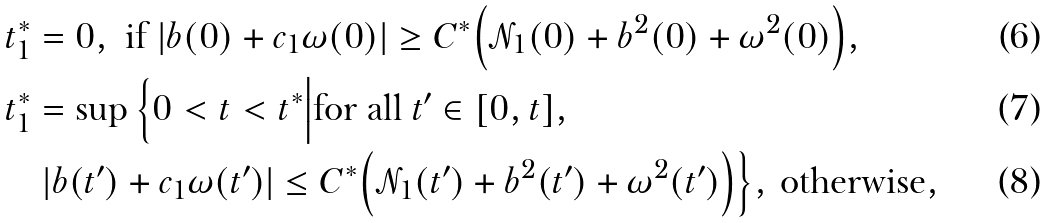<formula> <loc_0><loc_0><loc_500><loc_500>& t _ { 1 } ^ { * } = 0 , \text { if } | b ( 0 ) + c _ { 1 } \omega ( 0 ) | \geq C ^ { * } \Big ( \mathcal { N } _ { 1 } ( 0 ) + b ^ { 2 } ( 0 ) + \omega ^ { 2 } ( 0 ) \Big ) , \\ & t _ { 1 } ^ { * } = \sup \Big \{ 0 < t < t ^ { * } \Big | \text {for all } t ^ { \prime } \in [ 0 , t ] , \\ & \quad | b ( t ^ { \prime } ) + c _ { 1 } \omega ( t ^ { \prime } ) | \leq C ^ { * } \Big ( \mathcal { N } _ { 1 } ( t ^ { \prime } ) + b ^ { 2 } ( t ^ { \prime } ) + \omega ^ { 2 } ( t ^ { \prime } ) \Big ) \Big \} , \, \text {otherwise} ,</formula> 